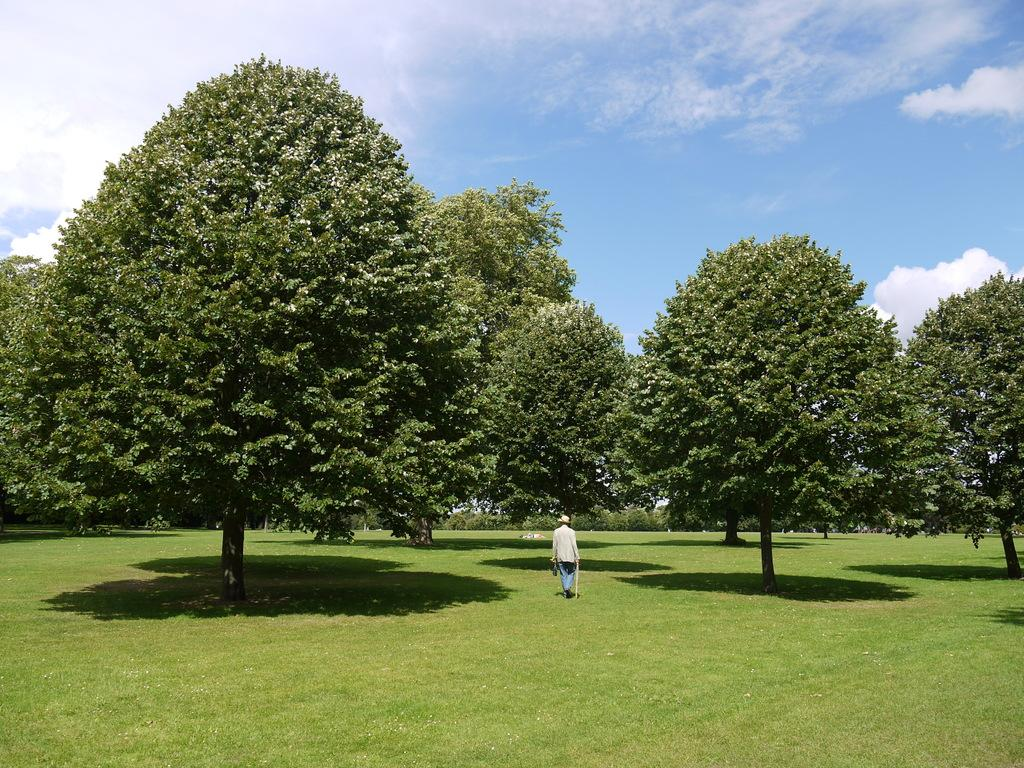Who or what is present in the image? There is a person in the image. What is the person wearing on their head? The person is wearing a hat. What object is the person holding in the image? The person is holding a stick. What type of vegetation can be seen in the image? There is grass visible in the image, and there are trees as well. What is visible in the background of the image? The sky is visible in the background of the image. Can you see a giraffe in the image? No, there is no giraffe present in the image. The image does not show a giraffe, as the facts provided only mention a person, a hat, a stick, grass, trees, and the sky. 